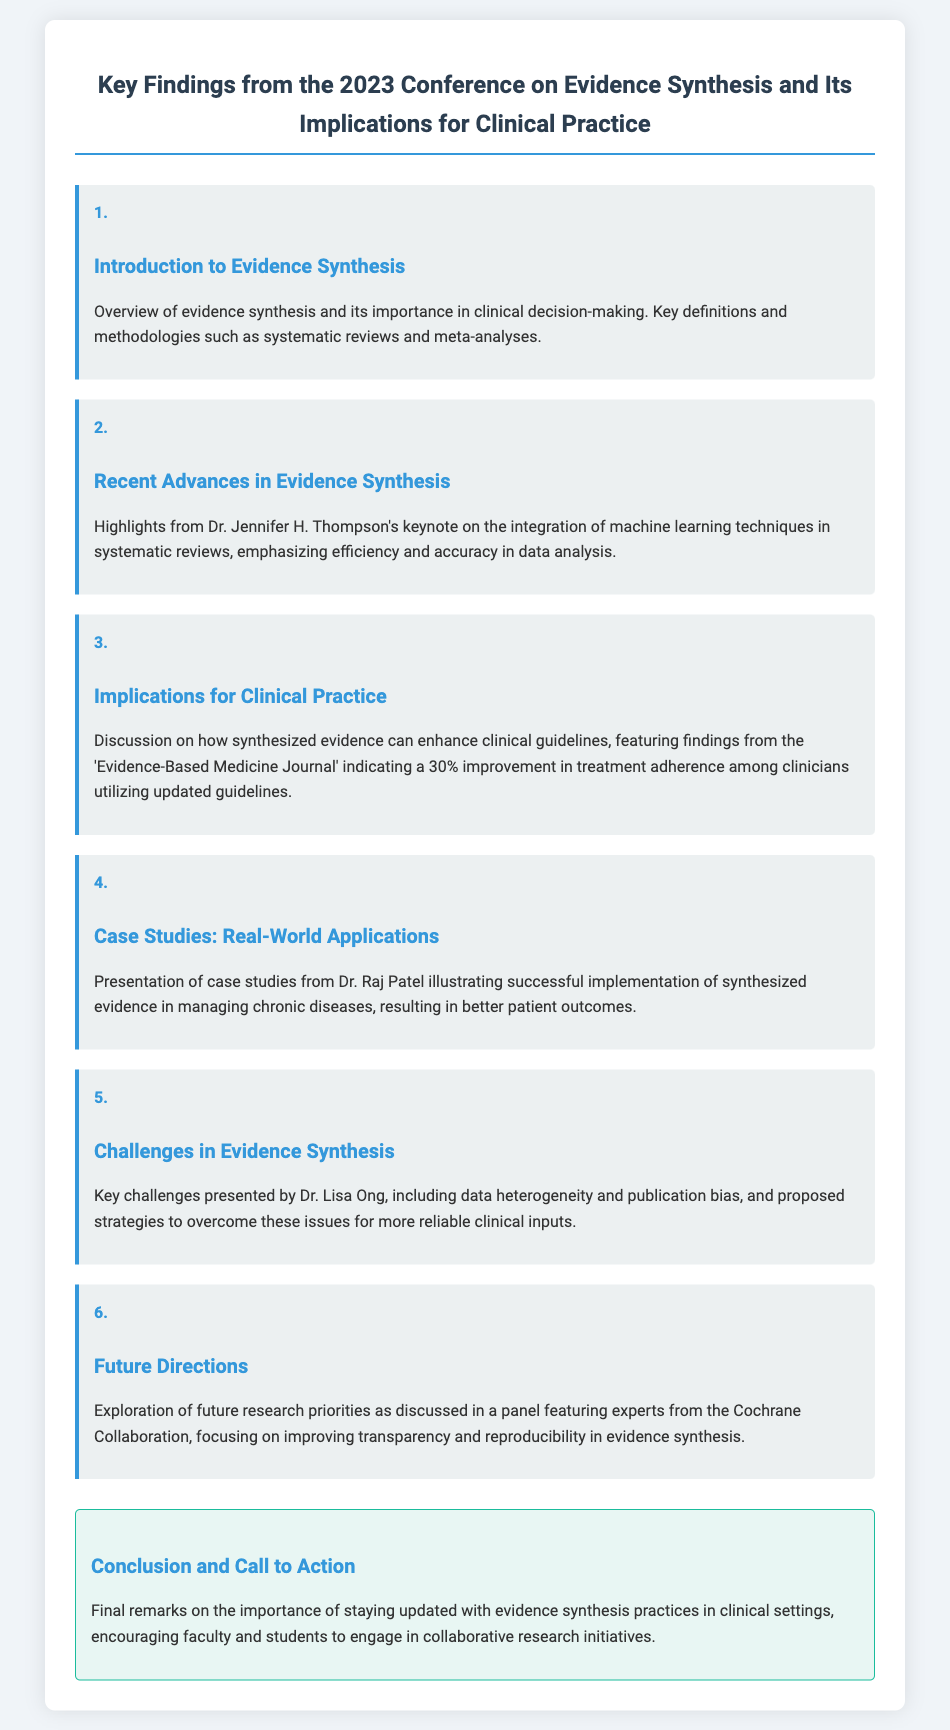What is the title of the presentation? The title of the presentation is stated at the top of the document.
Answer: Key Findings from the 2023 Conference on Evidence Synthesis and Its Implications for Clinical Practice Who delivered the keynote on machine learning techniques? The document specifies Dr. Jennifer H. Thompson as the keynote speaker on this topic.
Answer: Dr. Jennifer H. Thompson What percentage improvement in treatment adherence was indicated in the findings? The percentage improvement is mentioned in the slide discussing implications for clinical practice.
Answer: 30% What is one of the key challenges in evidence synthesis? The document lists challenges presented by Dr. Lisa Ong, which includes data heterogeneity.
Answer: Data heterogeneity Who illustrated case studies on the implementation of synthesized evidence? The document identifies Dr. Raj Patel as the presenter of these case studies.
Answer: Dr. Raj Patel What is a focus of future research priorities discussed in the panel? The document highlights the focus on improving transparency and reproducibility in evidence synthesis.
Answer: Transparency and reproducibility What is the call to action from the conclusion? The conclusion emphasizes the importance of engaging in collaborative research initiatives.
Answer: Engage in collaborative research initiatives What type of methodologies were defined in the introduction? The introduction mentions key methodologies such as systematic reviews and meta-analyses.
Answer: Systematic reviews and meta-analyses 